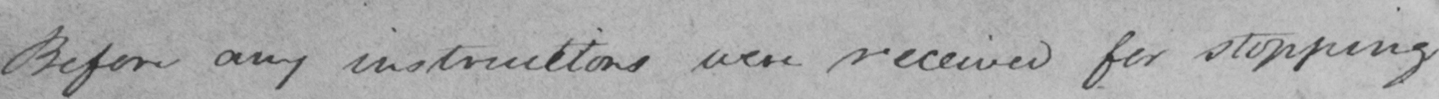What does this handwritten line say? Before any instructitions were received for stopping 